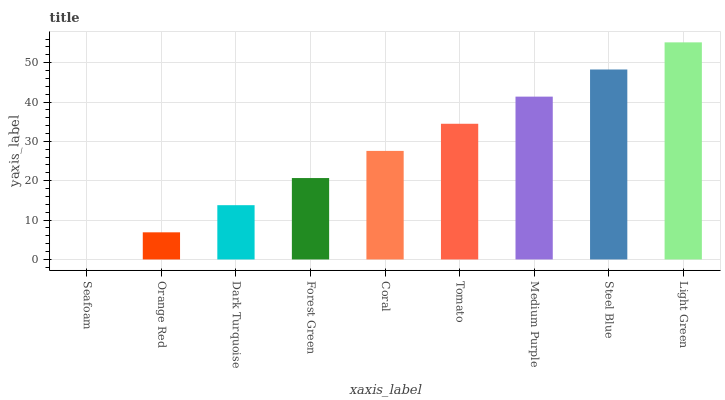Is Seafoam the minimum?
Answer yes or no. Yes. Is Light Green the maximum?
Answer yes or no. Yes. Is Orange Red the minimum?
Answer yes or no. No. Is Orange Red the maximum?
Answer yes or no. No. Is Orange Red greater than Seafoam?
Answer yes or no. Yes. Is Seafoam less than Orange Red?
Answer yes or no. Yes. Is Seafoam greater than Orange Red?
Answer yes or no. No. Is Orange Red less than Seafoam?
Answer yes or no. No. Is Coral the high median?
Answer yes or no. Yes. Is Coral the low median?
Answer yes or no. Yes. Is Light Green the high median?
Answer yes or no. No. Is Dark Turquoise the low median?
Answer yes or no. No. 